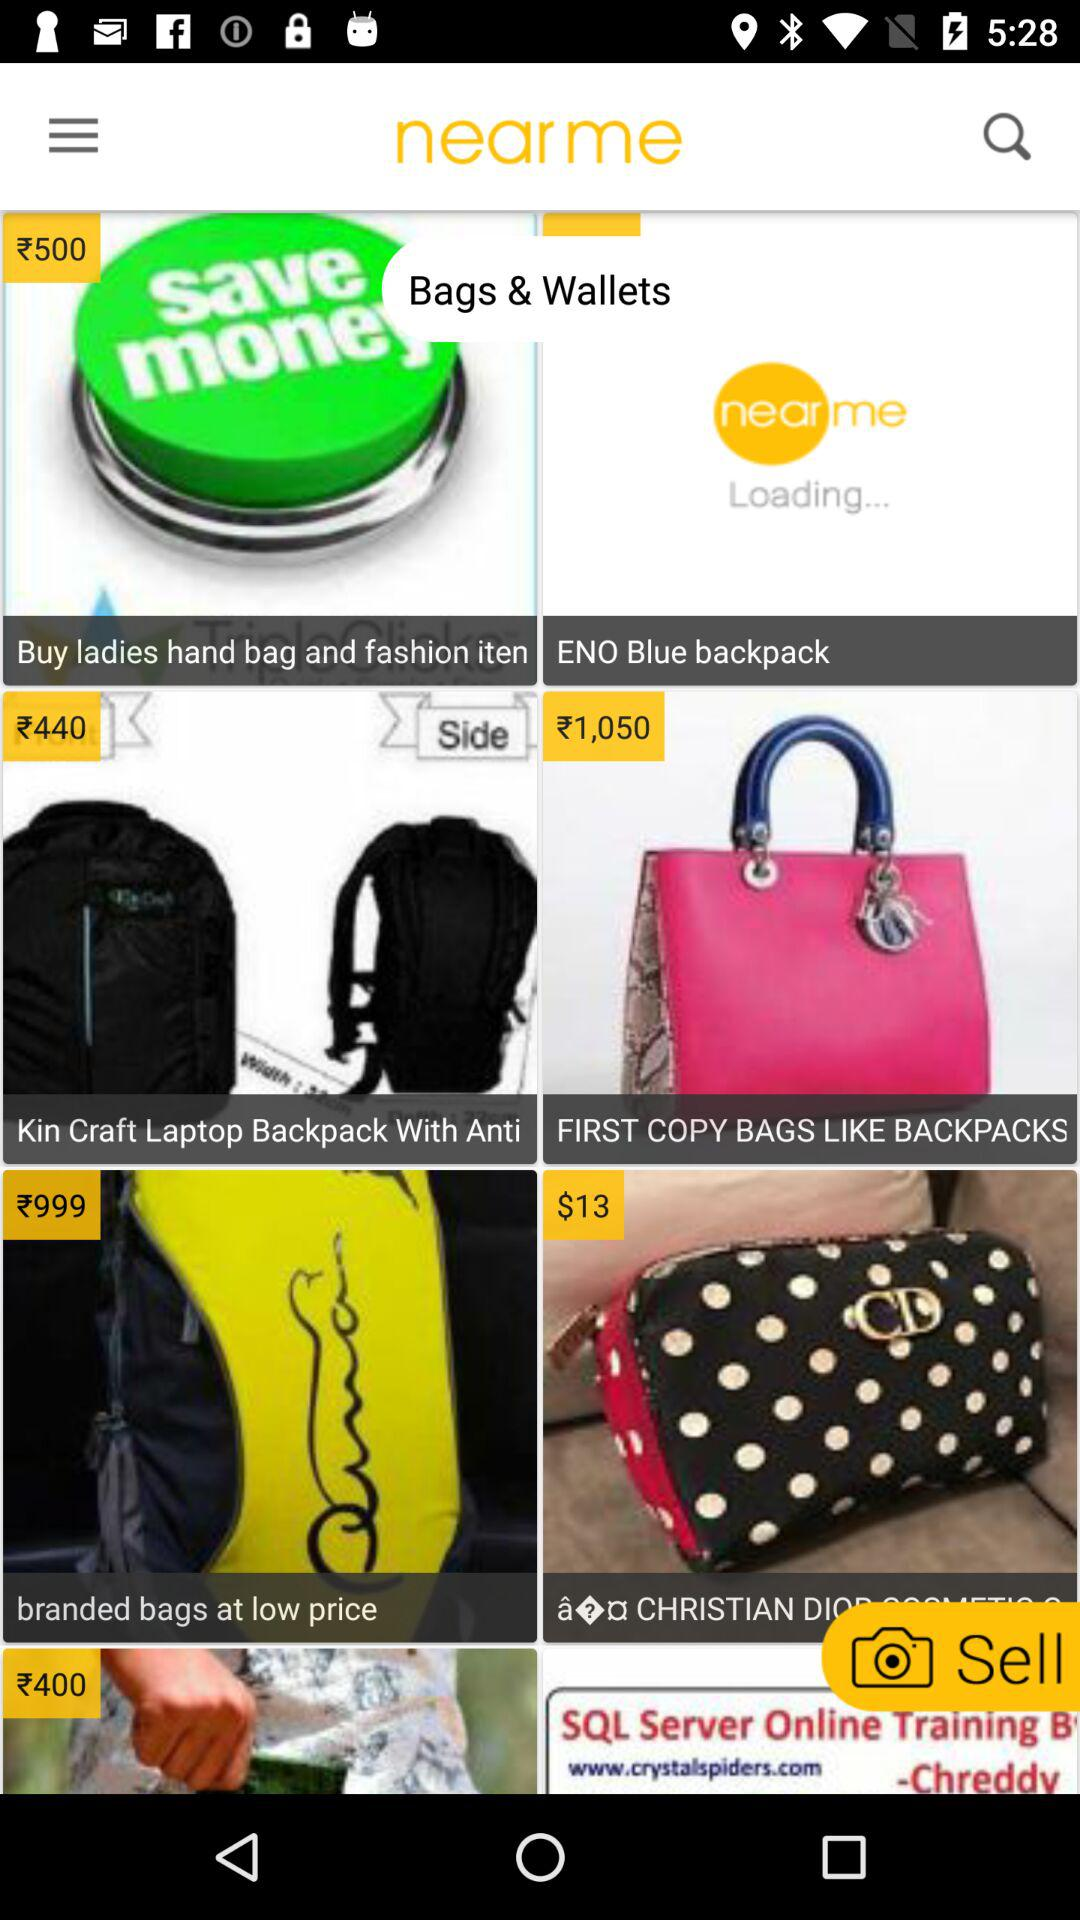What is the price of first-copy bags like backpacks? The price is ₹1,050. 